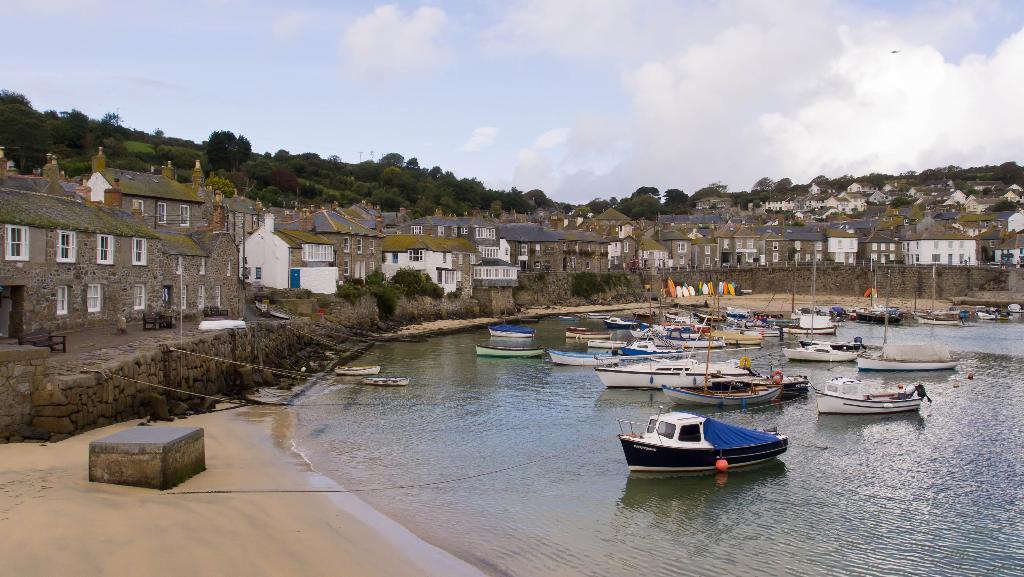Please provide a concise description of this image. In this picture there are ships on the water in the center of the image and there are houses on the right and left side of the image, there are trees in the background area of the image and there is sky at the top side of the image. 